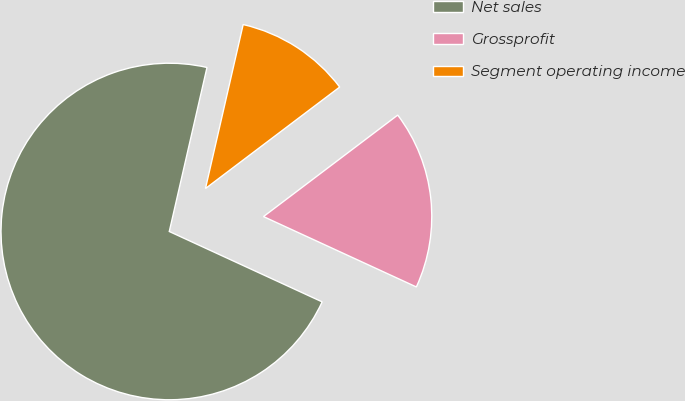Convert chart to OTSL. <chart><loc_0><loc_0><loc_500><loc_500><pie_chart><fcel>Net sales<fcel>Grossprofit<fcel>Segment operating income<nl><fcel>71.73%<fcel>17.17%<fcel>11.1%<nl></chart> 